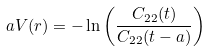<formula> <loc_0><loc_0><loc_500><loc_500>a V ( r ) = - \ln \left ( \frac { C _ { 2 2 } ( t ) } { C _ { 2 2 } ( t - a ) } \right )</formula> 